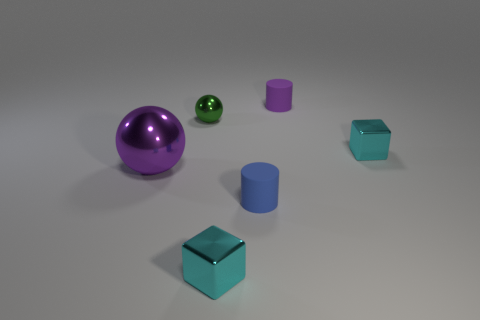Is the material of the green sphere the same as the purple thing on the right side of the green thing?
Provide a succinct answer. No. What color is the large thing?
Provide a short and direct response. Purple. Are there fewer small metallic objects in front of the purple metal thing than tiny blue cylinders?
Keep it short and to the point. No. Are there any other things that are the same shape as the big purple metal object?
Keep it short and to the point. Yes. Are there any large green metal things?
Ensure brevity in your answer.  No. Are there fewer large spheres than cyan shiny objects?
Provide a short and direct response. Yes. How many blue objects have the same material as the tiny purple object?
Offer a terse response. 1. What is the color of the other sphere that is the same material as the purple sphere?
Provide a succinct answer. Green. What is the shape of the blue matte thing?
Make the answer very short. Cylinder. How many cylinders are the same color as the large ball?
Keep it short and to the point. 1. 